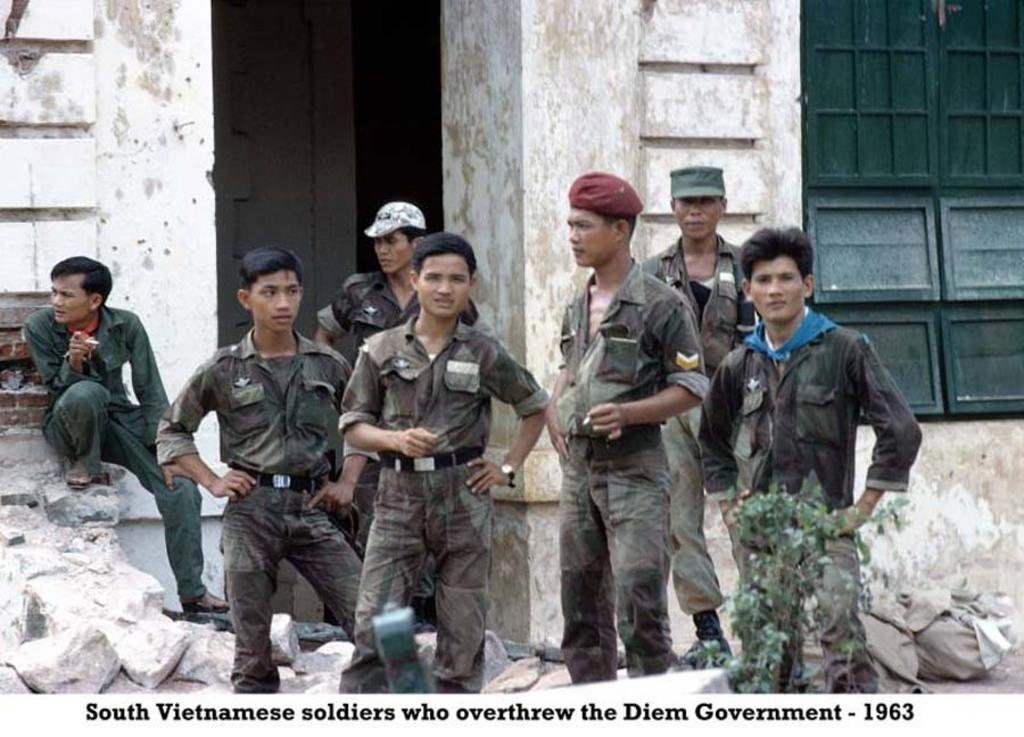Who is present in the image? There are people in the image. What are the people wearing? The people are wearing uniforms. Are there any specific accessories being worn by the people? Some of the people are wearing caps. Is there any text visible in the image? Yes, there is text visible in the image, possibly on the caps. What type of bread can be seen on the road in the image? There is no bread or road present in the image; it features people wearing uniforms and caps with visible text. 